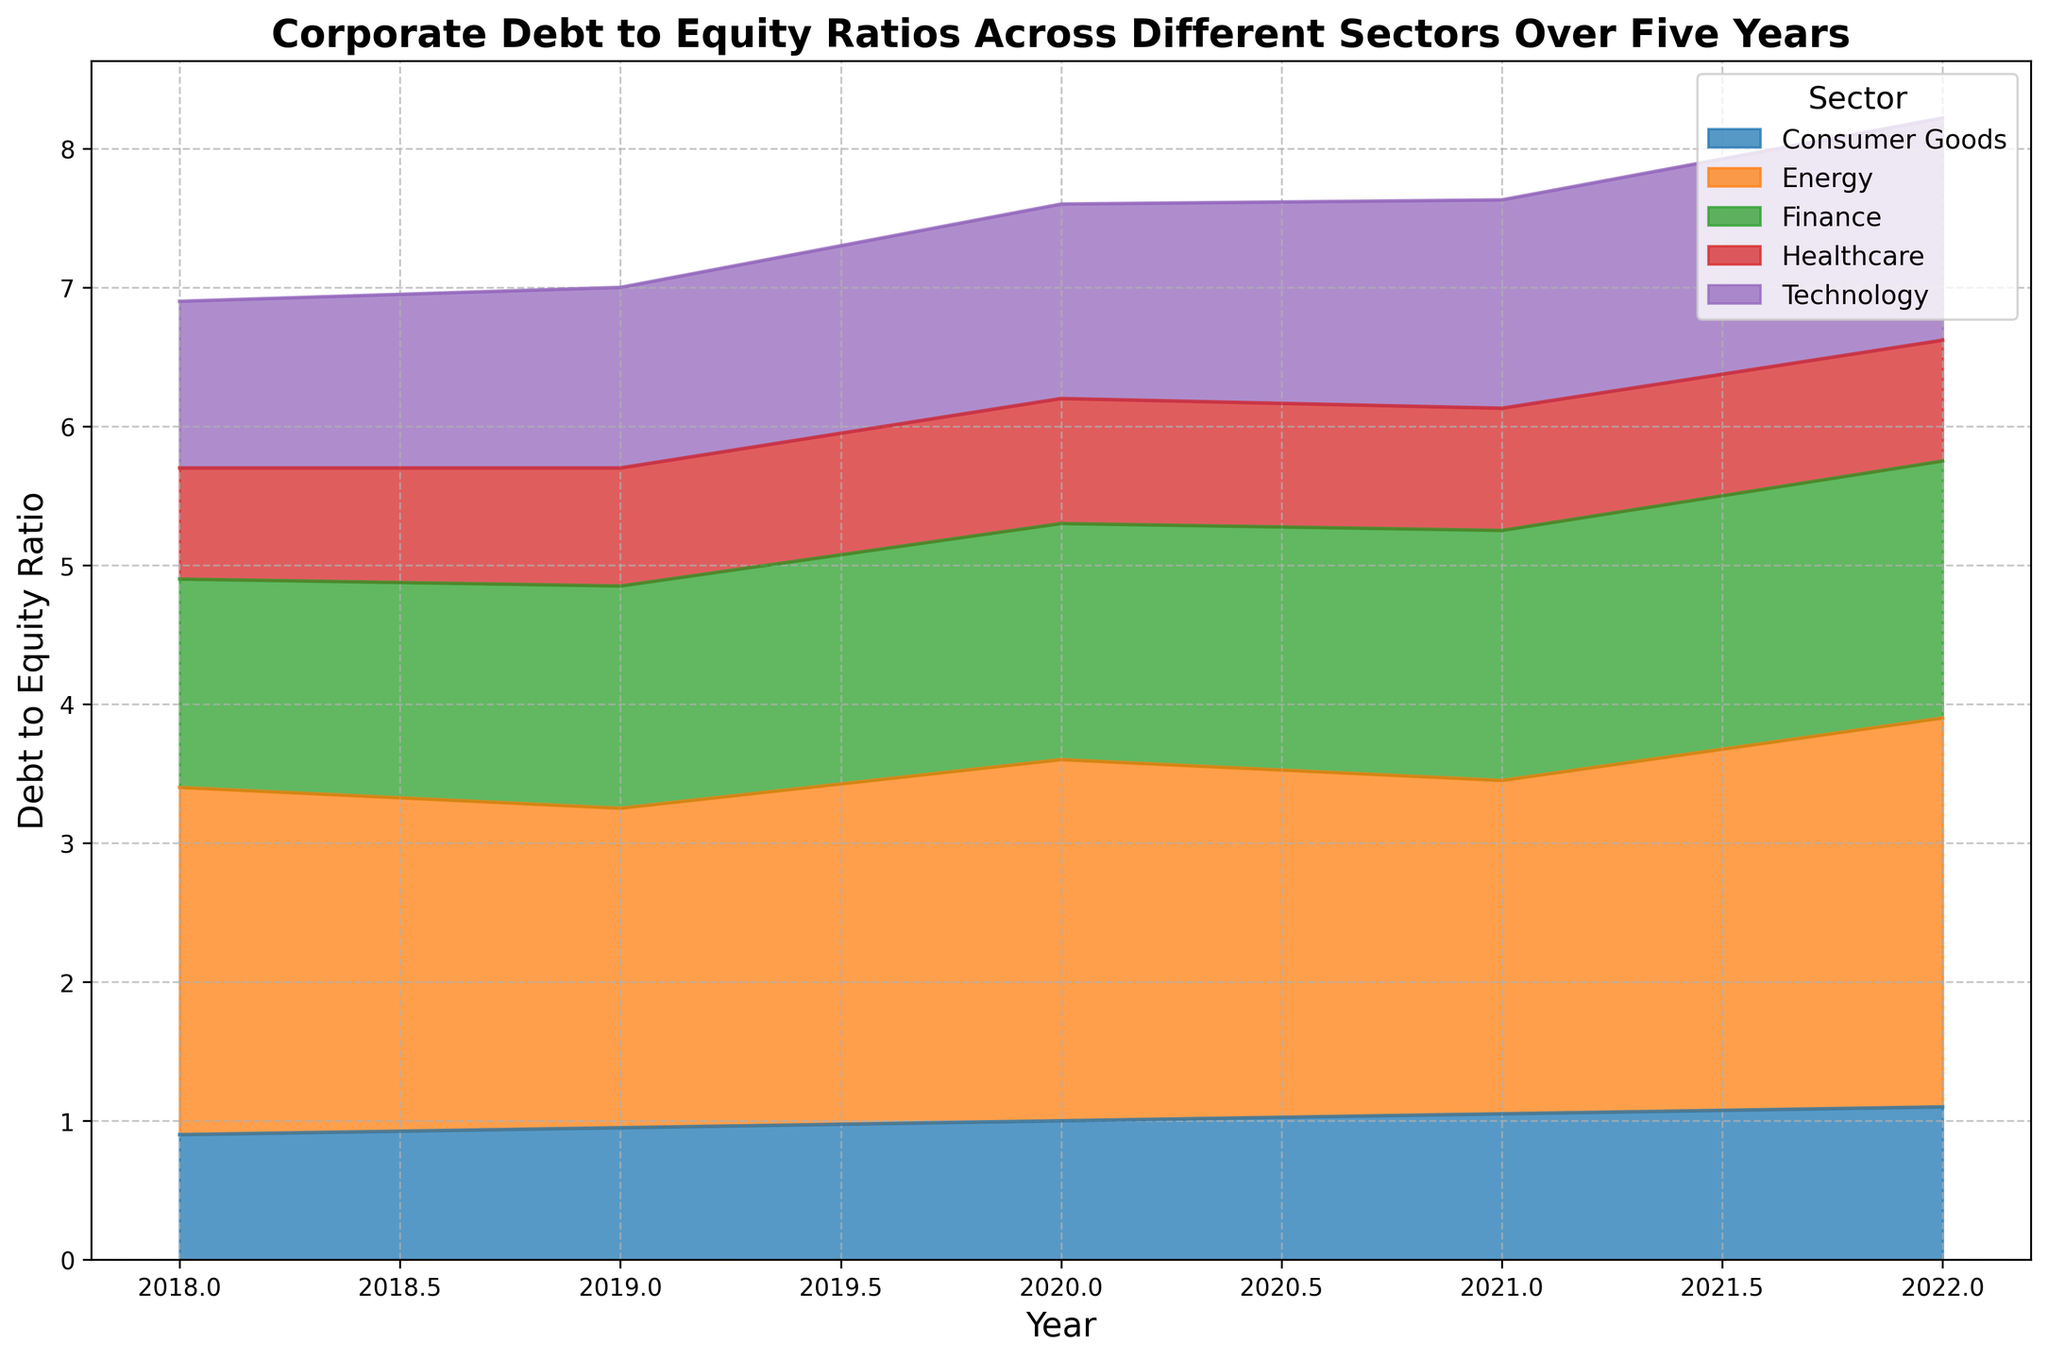What sector had the highest debt to equity ratio in 2022? Observing the plot for 2022, the sector with the most prominent area indicates the highest debt to equity ratio, which is Energy at 2.8.
Answer: Energy How did the debt to equity ratio for the Technology sector change from 2018 to 2022? The plot shows the area for technology starting at 1.2 in 2018 and gradually increasing to 1.6 in 2022. Calculating the difference (1.6 - 1.2 = 0.4) shows an increase of 0.4.
Answer: Increased by 0.4 Which sector showed the most consistent debt to equity ratio over the five years? By visually inspecting the areas, Healthcare's ratio appears relatively stable, fluctuating only from 0.8 to 0.9 to 0.85, 0.88, and 0.87 over the years, indicating minimal change.
Answer: Healthcare Between the Finance and Energy sectors, which one had a greater increase in debt to equity ratio from 2018 to 2022? Finance started at 1.5 and ended at 1.85, for a 0.35 increase. Energy started at 2.5 and ended at 2.8, for a 0.3 increase. Therefore, Finance had a greater increase (0.35 > 0.3).
Answer: Finance What is the sum of the debt to equity ratios for Consumer Goods across these five years? Summing up the ratios for Consumer Goods (0.9, 0.95, 1.0, 1.05, 1.1) results in 4.0.
Answer: 4.0 Which sector had an increasing trend in debt to equity ratio for each consecutive year from 2018 to 2022? Reviewing the plot for ongoing increases, Technology shows incremental growth each year from 1.2 in 2018 to 1.6 in 2022.
Answer: Technology Was the debt to equity ratio for Healthcare higher in 2020 or 2022? Observing the plot for Healthcare, the ratios in 2020 and 2022 are 0.9 and 0.87, respectively, indicating a higher ratio in 2020.
Answer: 2020 In which year did Finance surpass a debt to equity ratio of 1.7? On the plot, Finance reaches beyond 1.7 in 2021, marking its debt to equity ratio as 1.8.
Answer: 2021 